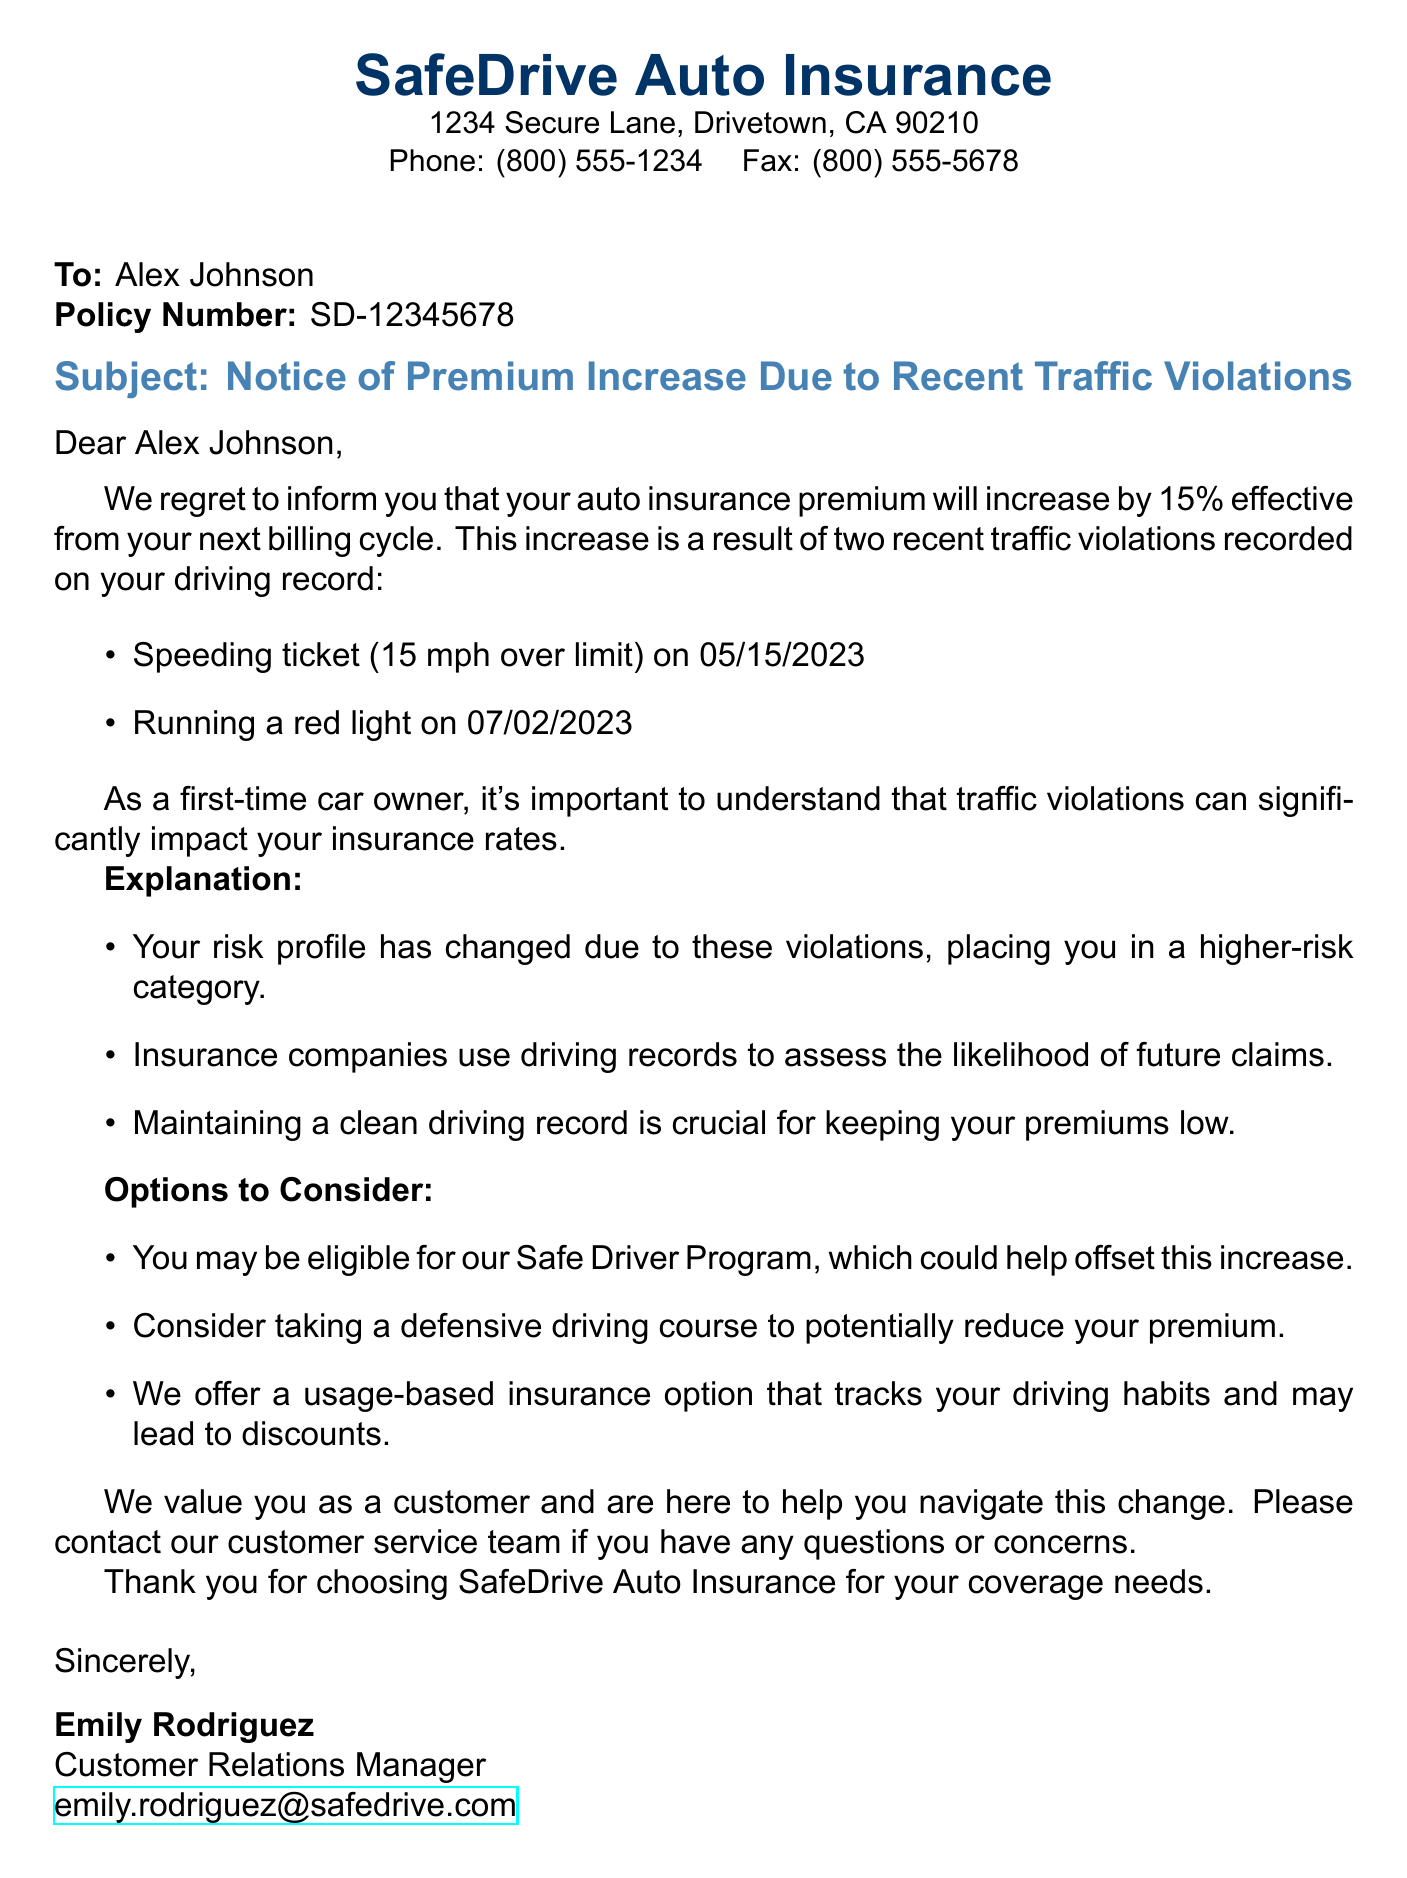What is the name of the insurance company? The document identifies the insurance company as "SafeDrive Auto Insurance."
Answer: SafeDrive Auto Insurance Who is the recipient of the notice? The fax is addressed to "Alex Johnson," making him the recipient of the notice.
Answer: Alex Johnson What is the percentage increase in the premium? The document states that the premium will increase by 15%.
Answer: 15% When did the speeding violation occur? The document specifies that the speeding violation occurred on "05/15/2023."
Answer: 05/15/2023 What is one option to potentially reduce the premium? The document mentions that taking a defensive driving course could help in reducing the premium.
Answer: Defensive driving course Who is the sender of the fax? The document is signed by "Emily Rodriguez," identifying her as the sender.
Answer: Emily Rodriguez What is the policy number mentioned in the notice? The policy number provided in the document is "SD-12345678."
Answer: SD-12345678 What type of program might offset the premium increase? The document suggests that the recipient may be eligible for the "Safe Driver Program."
Answer: Safe Driver Program How many traffic violations are mentioned? The document refers to a total of two traffic violations that have contributed to the premium increase.
Answer: Two 